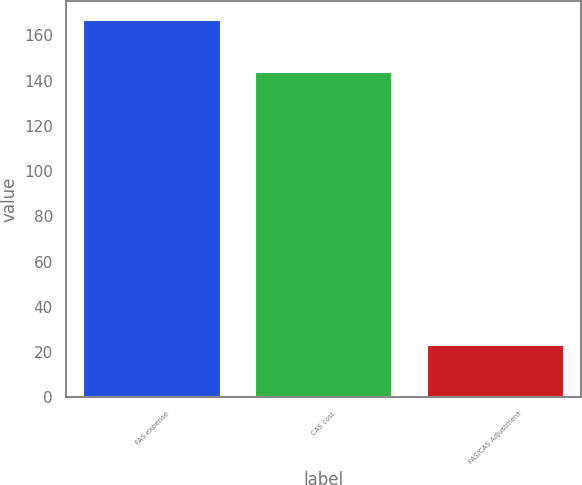<chart> <loc_0><loc_0><loc_500><loc_500><bar_chart><fcel>FAS expense<fcel>CAS cost<fcel>FAS/CAS Adjustment<nl><fcel>167<fcel>144<fcel>23<nl></chart> 